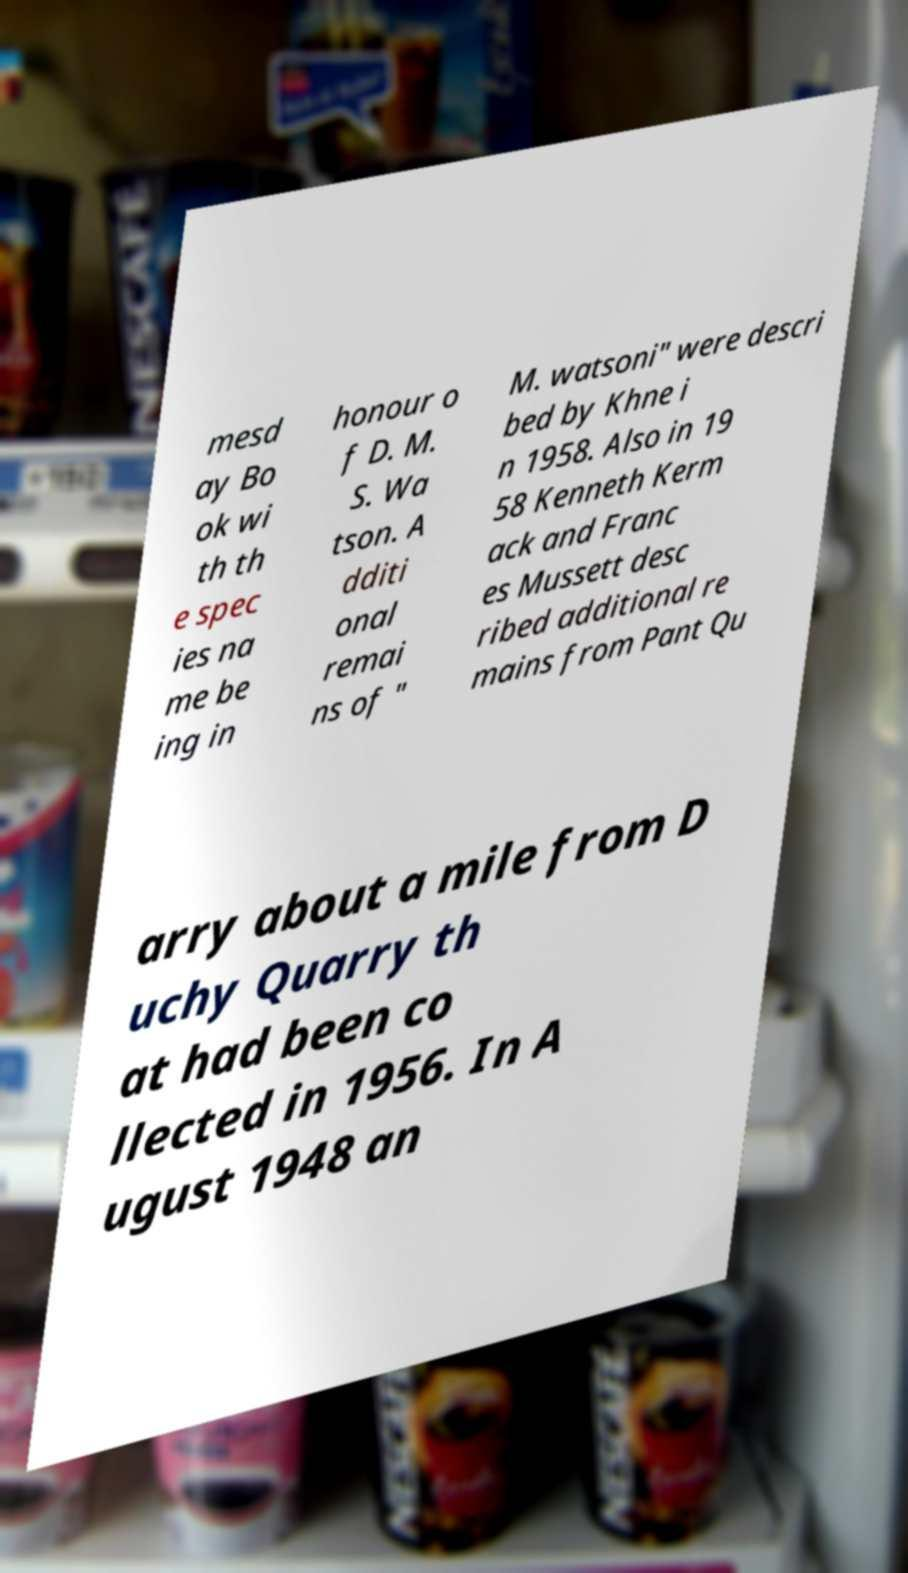Could you extract and type out the text from this image? mesd ay Bo ok wi th th e spec ies na me be ing in honour o f D. M. S. Wa tson. A dditi onal remai ns of " M. watsoni" were descri bed by Khne i n 1958. Also in 19 58 Kenneth Kerm ack and Franc es Mussett desc ribed additional re mains from Pant Qu arry about a mile from D uchy Quarry th at had been co llected in 1956. In A ugust 1948 an 